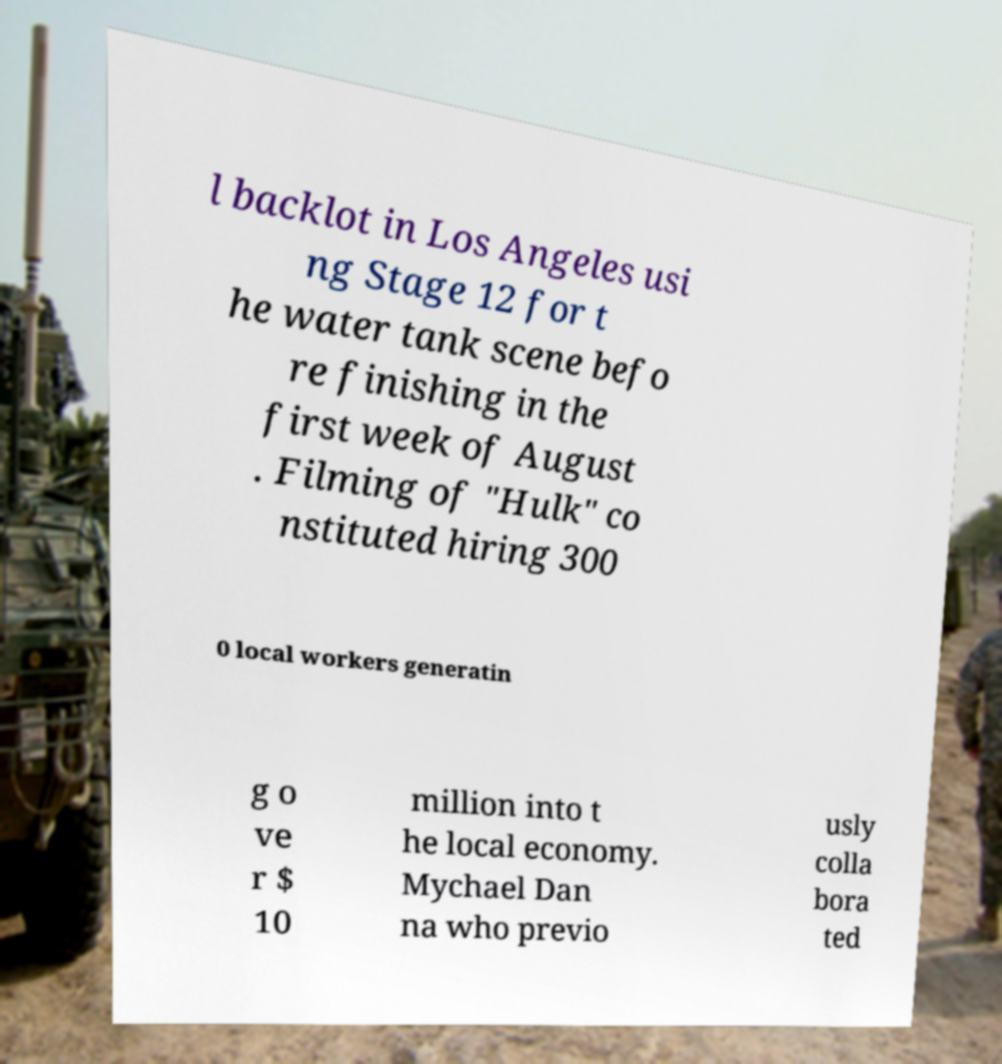Could you extract and type out the text from this image? l backlot in Los Angeles usi ng Stage 12 for t he water tank scene befo re finishing in the first week of August . Filming of "Hulk" co nstituted hiring 300 0 local workers generatin g o ve r $ 10 million into t he local economy. Mychael Dan na who previo usly colla bora ted 